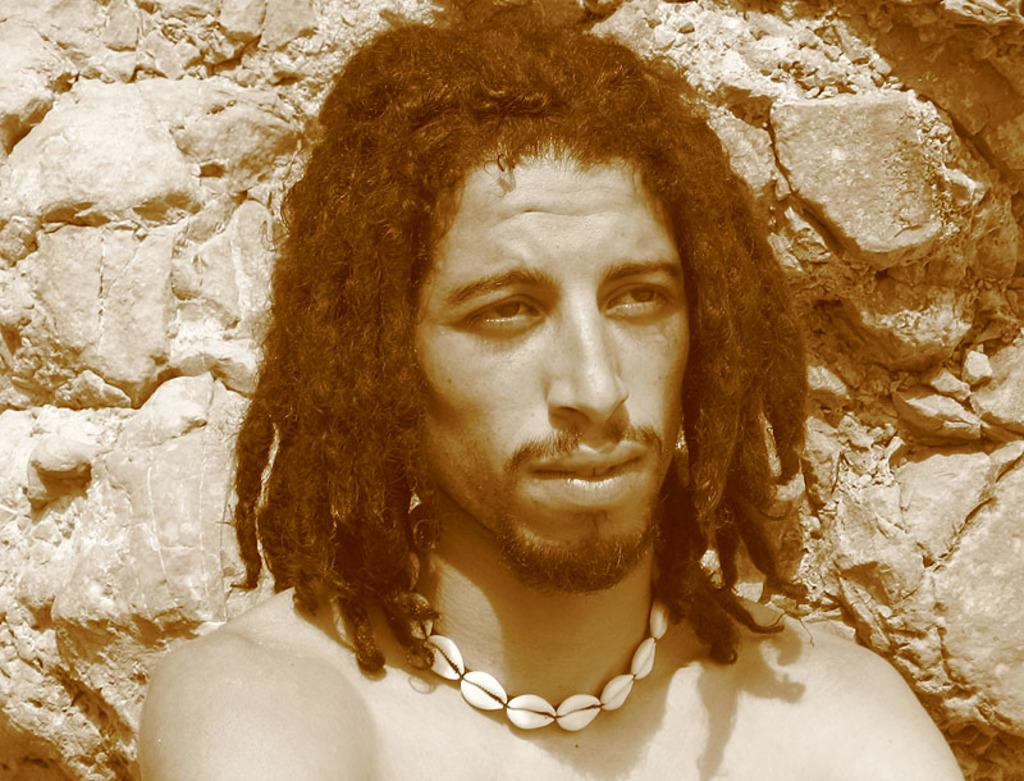Who is present in the image? There is a man in the image. What is the man wearing around his neck? The man is wearing a chain made up of seashells. Can you describe the man's hair? The man has long hair. What can be seen in the background of the image? There are rocks visible in the background of the image. What type of fan is visible in the image? There is no fan present in the image. Is the man attending a meeting in the image? There is no indication of a meeting in the image; it only features a man with a seashell necklace and long hair, standing in front of rocks. 